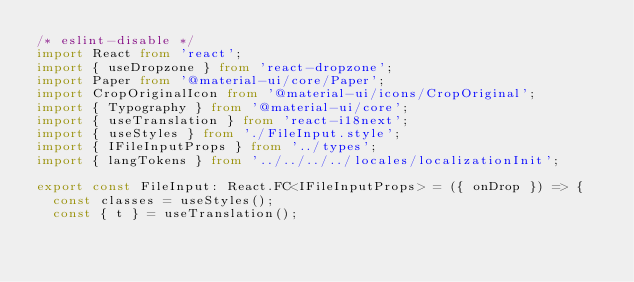<code> <loc_0><loc_0><loc_500><loc_500><_TypeScript_>/* eslint-disable */
import React from 'react';
import { useDropzone } from 'react-dropzone';
import Paper from '@material-ui/core/Paper';
import CropOriginalIcon from '@material-ui/icons/CropOriginal';
import { Typography } from '@material-ui/core';
import { useTranslation } from 'react-i18next';
import { useStyles } from './FileInput.style';
import { IFileInputProps } from '../types';
import { langTokens } from '../../../../locales/localizationInit';

export const FileInput: React.FC<IFileInputProps> = ({ onDrop }) => {
  const classes = useStyles();
  const { t } = useTranslation();</code> 